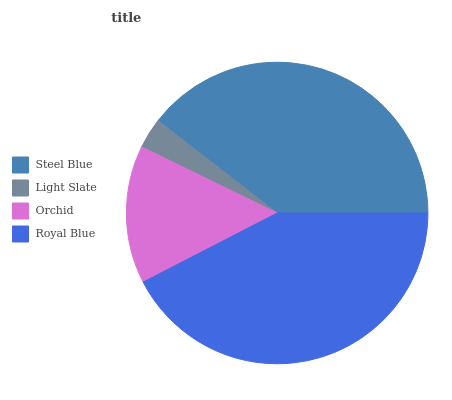Is Light Slate the minimum?
Answer yes or no. Yes. Is Royal Blue the maximum?
Answer yes or no. Yes. Is Orchid the minimum?
Answer yes or no. No. Is Orchid the maximum?
Answer yes or no. No. Is Orchid greater than Light Slate?
Answer yes or no. Yes. Is Light Slate less than Orchid?
Answer yes or no. Yes. Is Light Slate greater than Orchid?
Answer yes or no. No. Is Orchid less than Light Slate?
Answer yes or no. No. Is Steel Blue the high median?
Answer yes or no. Yes. Is Orchid the low median?
Answer yes or no. Yes. Is Orchid the high median?
Answer yes or no. No. Is Steel Blue the low median?
Answer yes or no. No. 